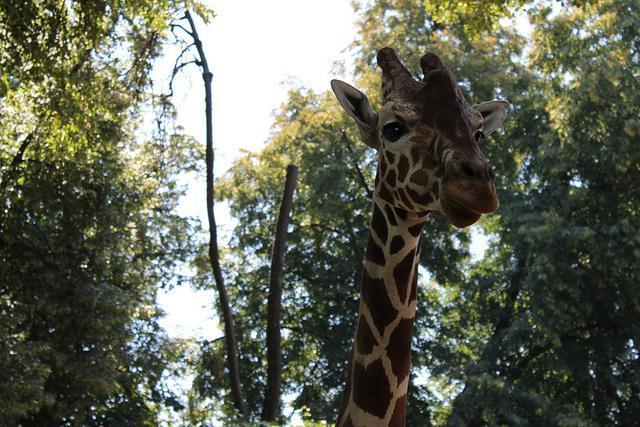How many giraffes are pictured?
Give a very brief answer. 1. How many people are standing on the hill?
Give a very brief answer. 0. 